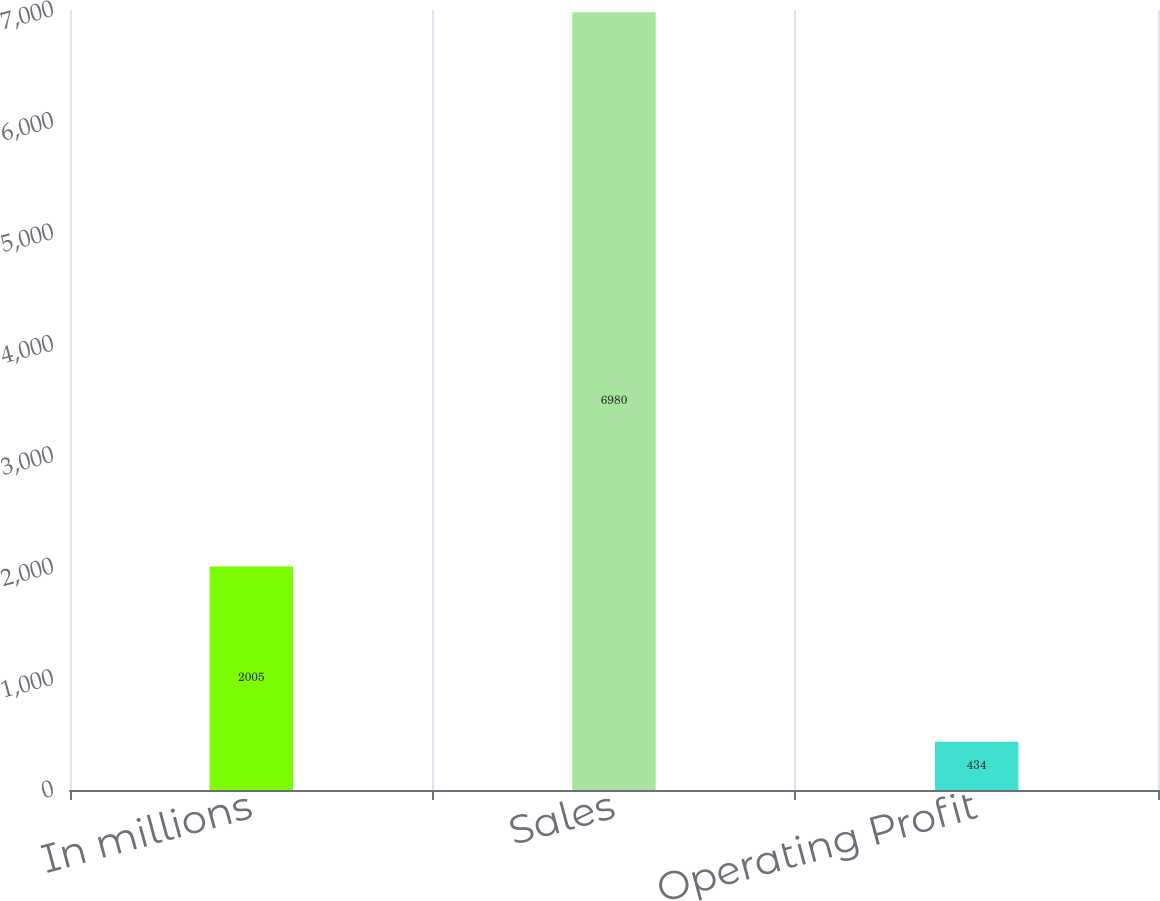Convert chart. <chart><loc_0><loc_0><loc_500><loc_500><bar_chart><fcel>In millions<fcel>Sales<fcel>Operating Profit<nl><fcel>2005<fcel>6980<fcel>434<nl></chart> 